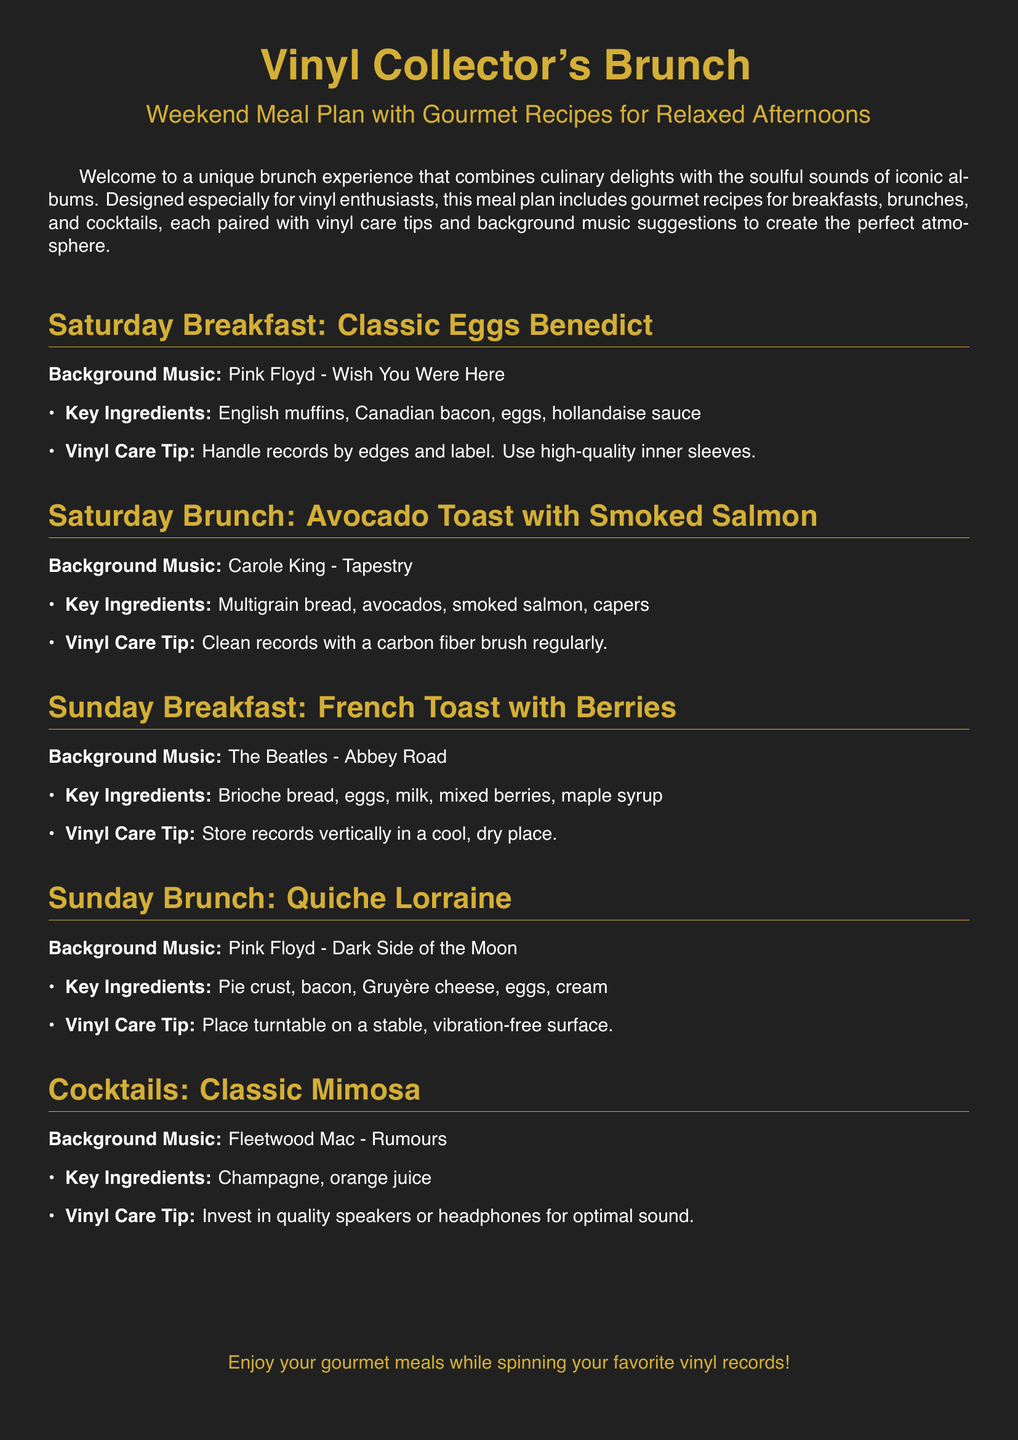What is the title of the meal plan? The title of the meal plan is prominently displayed at the top of the document.
Answer: Vinyl Collector's Brunch Which cocktail is included in the meal plan? The meal plan features several sections, one of which includes cocktails specifically.
Answer: Classic Mimosa What background music is suggested for Saturday Brunch? The document lists background music suggestions alongside each meal for creating the right atmosphere.
Answer: Carole King - Tapestry What is a key ingredient in the French Toast? The document provides a list of key ingredients for each meal.
Answer: Brioche bread How many recipes are included for Sunday? By counting the sections dedicated to Sunday, we can determine the number of recipes provided for that day.
Answer: Two What is a vinyl care tip for handling records? The meal plan gives specific tips for vinyl care in conjunction with meal recipes.
Answer: Handle records by edges and label Which album is associated with the breakfast on Sunday? Each meal is paired with a specific album, which can be found in the respective section.
Answer: The Beatles - Abbey Road What is the main ingredient in the Quiche Lorraine? The ingredients are listed in each section, allowing us to identify the main ingredient for the Quiche Lorraine.
Answer: Bacon 